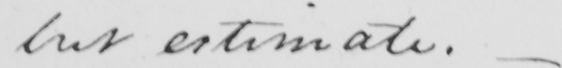Please provide the text content of this handwritten line. but estimate .  _ 